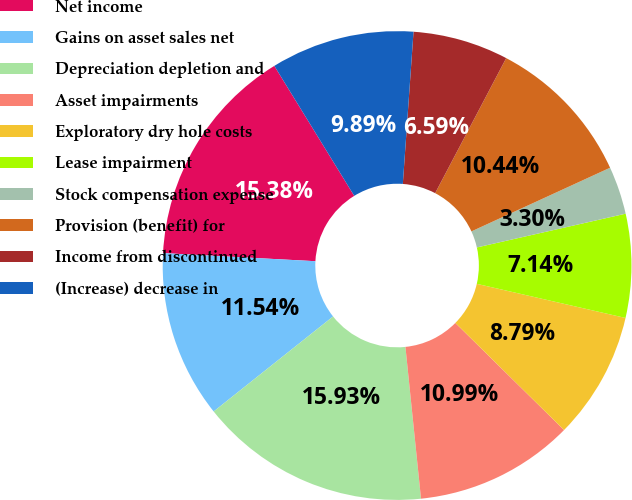<chart> <loc_0><loc_0><loc_500><loc_500><pie_chart><fcel>Net income<fcel>Gains on asset sales net<fcel>Depreciation depletion and<fcel>Asset impairments<fcel>Exploratory dry hole costs<fcel>Lease impairment<fcel>Stock compensation expense<fcel>Provision (benefit) for<fcel>Income from discontinued<fcel>(Increase) decrease in<nl><fcel>15.38%<fcel>11.54%<fcel>15.93%<fcel>10.99%<fcel>8.79%<fcel>7.14%<fcel>3.3%<fcel>10.44%<fcel>6.59%<fcel>9.89%<nl></chart> 